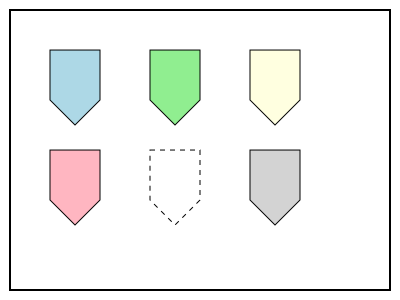In this puzzle designed for children with Down Syndrome, one piece is missing. Which shape and color should the missing piece be to complete the pattern? To solve this puzzle, we need to analyze the pattern:

1. The puzzle consists of 6 spaces arranged in a 2x3 grid.
2. Each piece has the same pentagon shape with a pointed bottom.
3. 5 out of 6 spaces are filled with colored pieces.
4. The colors used are: lightblue, lightgreen, lightyellow, lightpink, and lightgray.
5. The missing piece is in the middle of the bottom row, indicated by a dashed outline.
6. To maintain the pattern, the missing piece should have the same pentagon shape as the others.
7. The only color not used yet is lightgreen.

Therefore, to complete the pattern, the missing piece should be a pentagon shape filled with lightgreen color.

This type of puzzle helps children with Down Syndrome develop their spatial intelligence and color recognition skills.
Answer: Pentagon shape, lightgreen color 